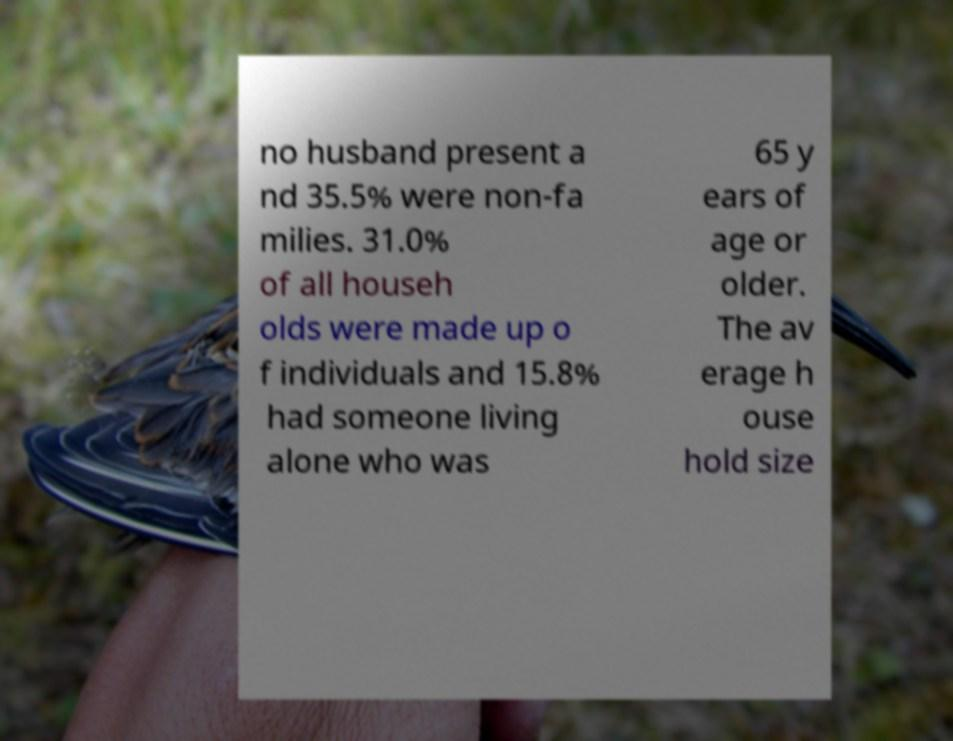What messages or text are displayed in this image? I need them in a readable, typed format. no husband present a nd 35.5% were non-fa milies. 31.0% of all househ olds were made up o f individuals and 15.8% had someone living alone who was 65 y ears of age or older. The av erage h ouse hold size 